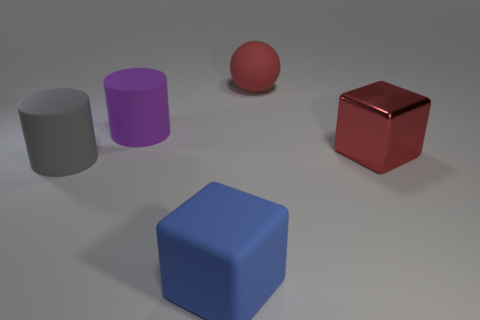Add 2 large red things. How many objects exist? 7 Subtract all balls. How many objects are left? 4 Subtract 0 yellow balls. How many objects are left? 5 Subtract all small blocks. Subtract all gray matte objects. How many objects are left? 4 Add 1 matte cylinders. How many matte cylinders are left? 3 Add 1 small rubber blocks. How many small rubber blocks exist? 1 